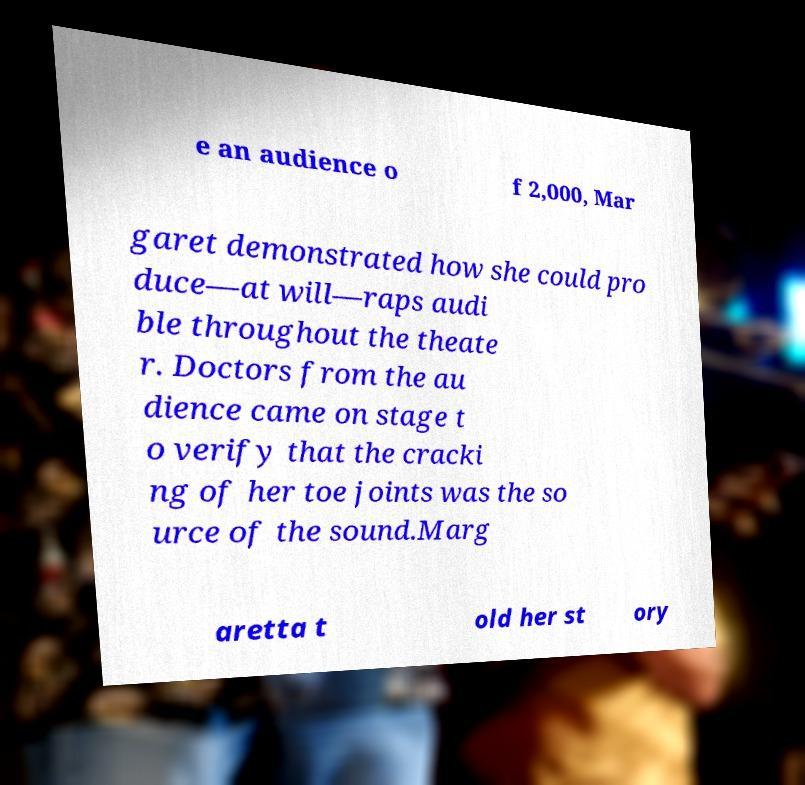There's text embedded in this image that I need extracted. Can you transcribe it verbatim? e an audience o f 2,000, Mar garet demonstrated how she could pro duce—at will—raps audi ble throughout the theate r. Doctors from the au dience came on stage t o verify that the cracki ng of her toe joints was the so urce of the sound.Marg aretta t old her st ory 